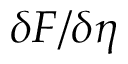<formula> <loc_0><loc_0><loc_500><loc_500>\delta F / \delta \eta</formula> 